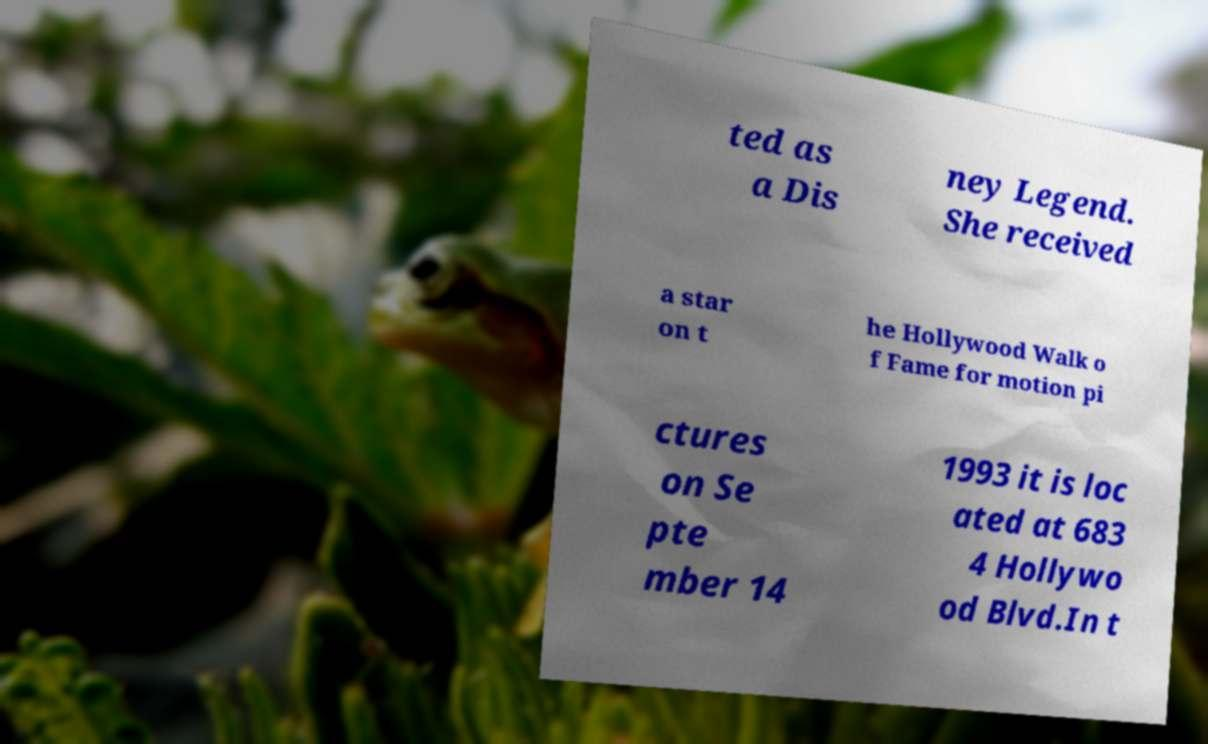Could you assist in decoding the text presented in this image and type it out clearly? ted as a Dis ney Legend. She received a star on t he Hollywood Walk o f Fame for motion pi ctures on Se pte mber 14 1993 it is loc ated at 683 4 Hollywo od Blvd.In t 